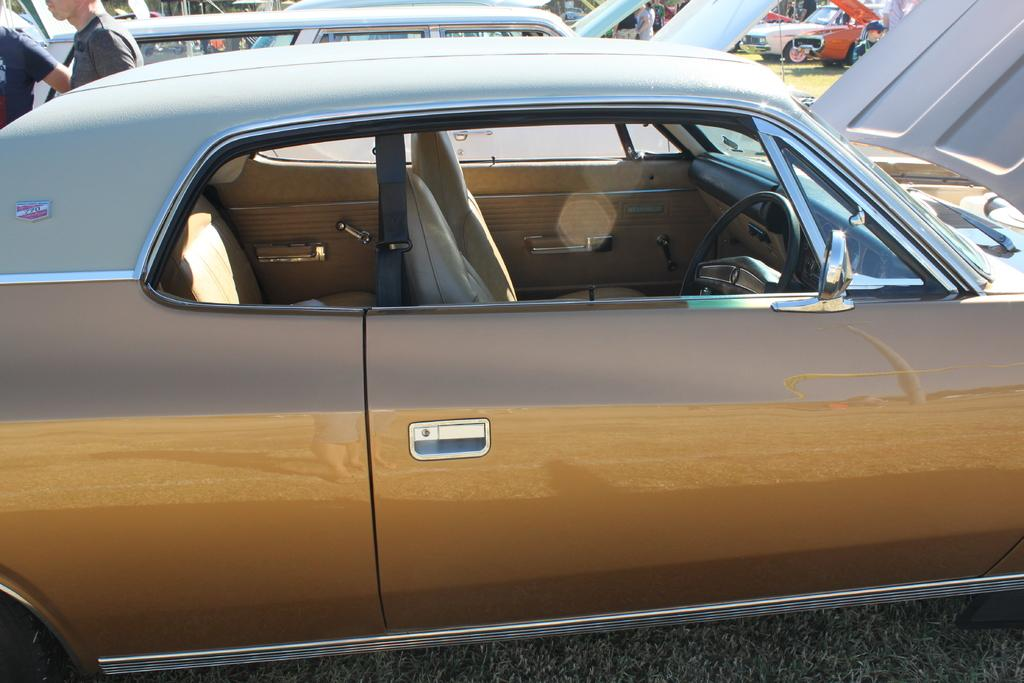What is located in the center of the image? There are vehicles in the center of the image. What type of natural environment can be seen in the image? There is grass visible in the image. Can you describe the people in the image? There are people standing in the image, and some of them are holding objects. What other objects are present in the image besides the vehicles and people? There are other objects present in the image. What type of eggnog is being served in the image? There is no eggnog present in the image. How many centimeters are the people lifting in the image? There is no indication of people lifting anything in the image. 